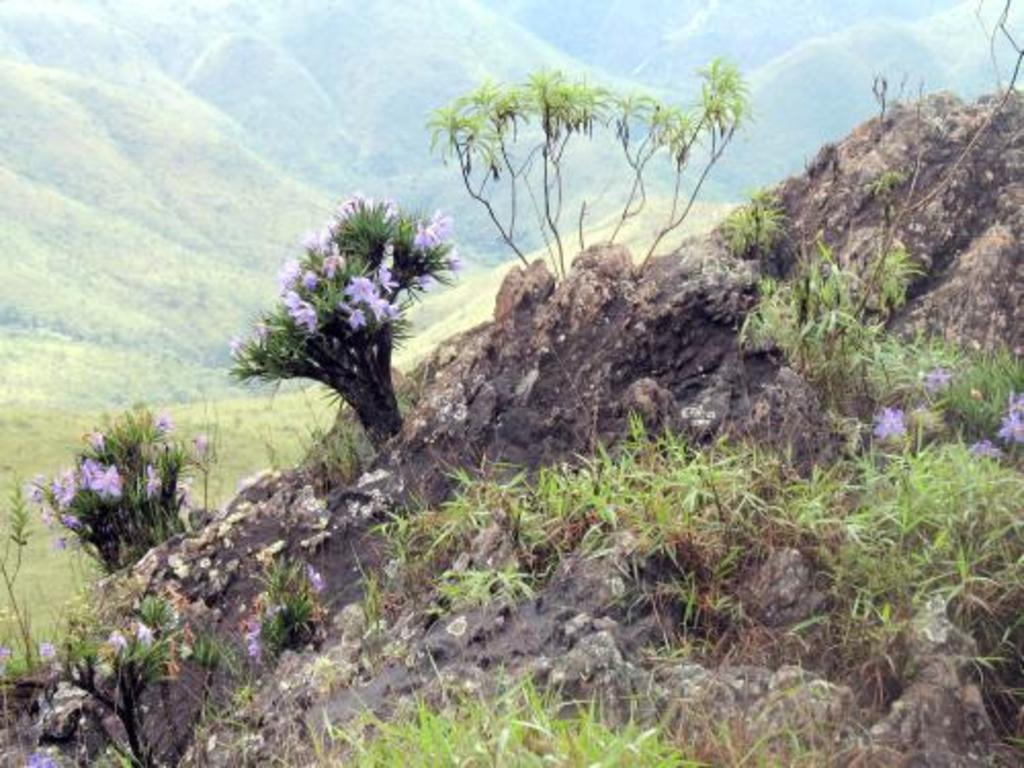What type of plants can be seen on the hill in the image? There are plants with blue flowers on the hill in the image. What else can be found on the hill besides the blue-flowered plants? The hill has grass and other plants. What is visible in the background of the image? There are mountains in the background of the image. How many boys are holding the chin of the bear in the image? There are no boys or bears present in the image; it features plants with blue flowers on a hill with grass and other plants, and mountains in the background. 